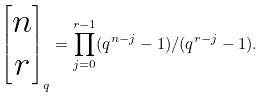Convert formula to latex. <formula><loc_0><loc_0><loc_500><loc_500>\begin{bmatrix} n \\ r \\ \end{bmatrix} _ { q } = \prod _ { j = 0 } ^ { r - 1 } ( q ^ { n - j } - 1 ) / ( q ^ { r - j } - 1 ) .</formula> 